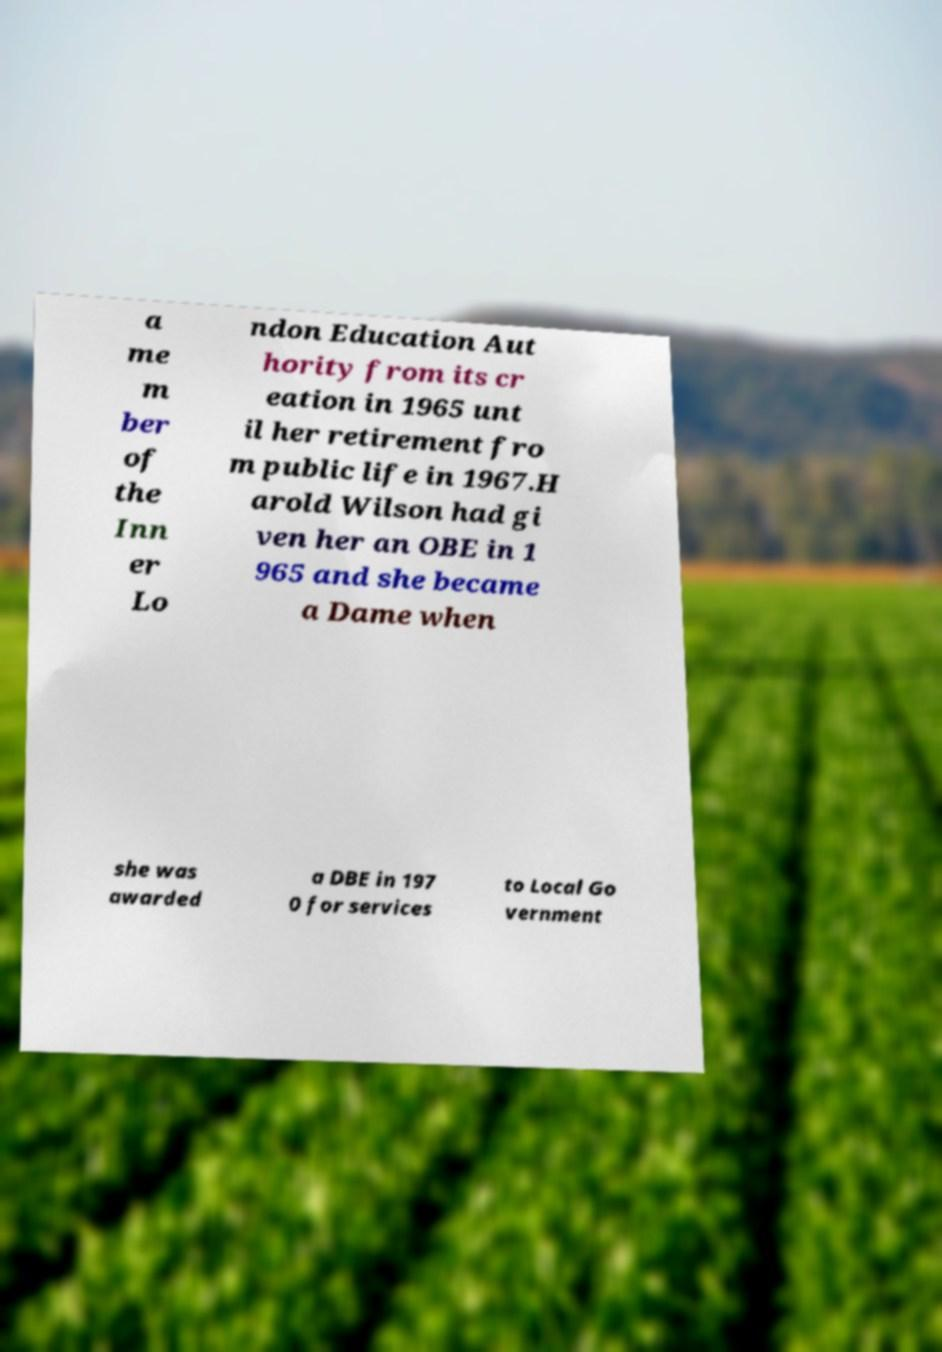Please read and relay the text visible in this image. What does it say? a me m ber of the Inn er Lo ndon Education Aut hority from its cr eation in 1965 unt il her retirement fro m public life in 1967.H arold Wilson had gi ven her an OBE in 1 965 and she became a Dame when she was awarded a DBE in 197 0 for services to Local Go vernment 